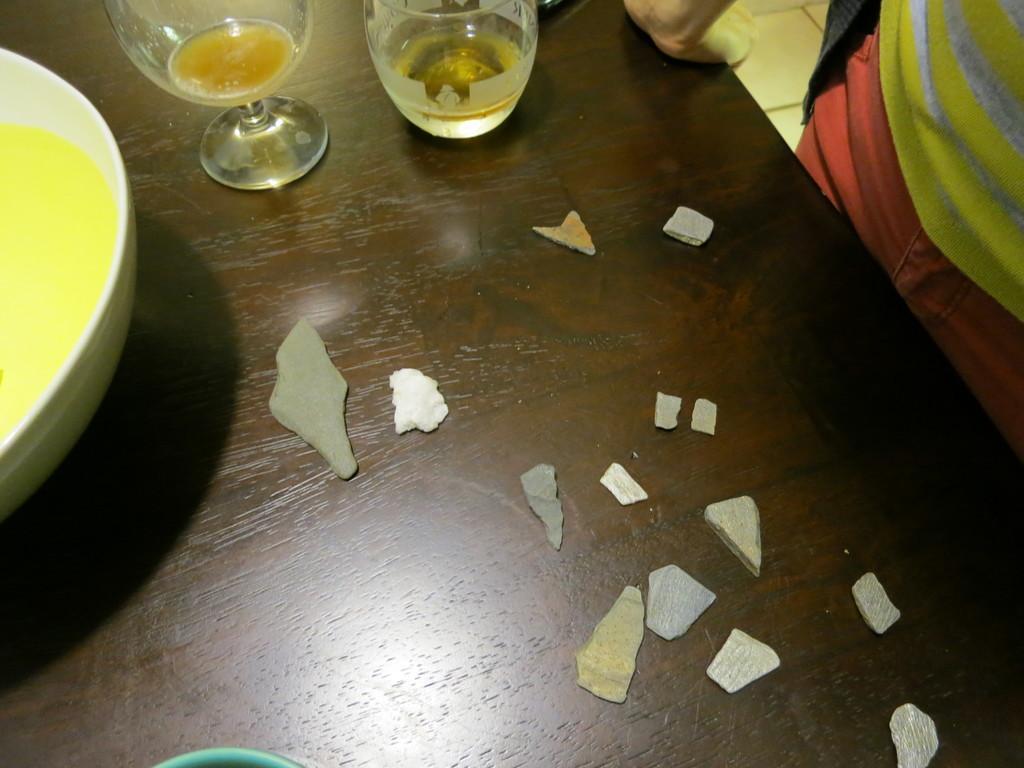Could you give a brief overview of what you see in this image? On the brown color table there are some stones. On the top side corner there are two glasses. To the left there is a bowl,with food item. And to the right side top there is a man standing with blue, yellow color t-shirt. 